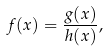<formula> <loc_0><loc_0><loc_500><loc_500>f ( x ) = { \frac { g ( x ) } { h ( x ) } } ,</formula> 